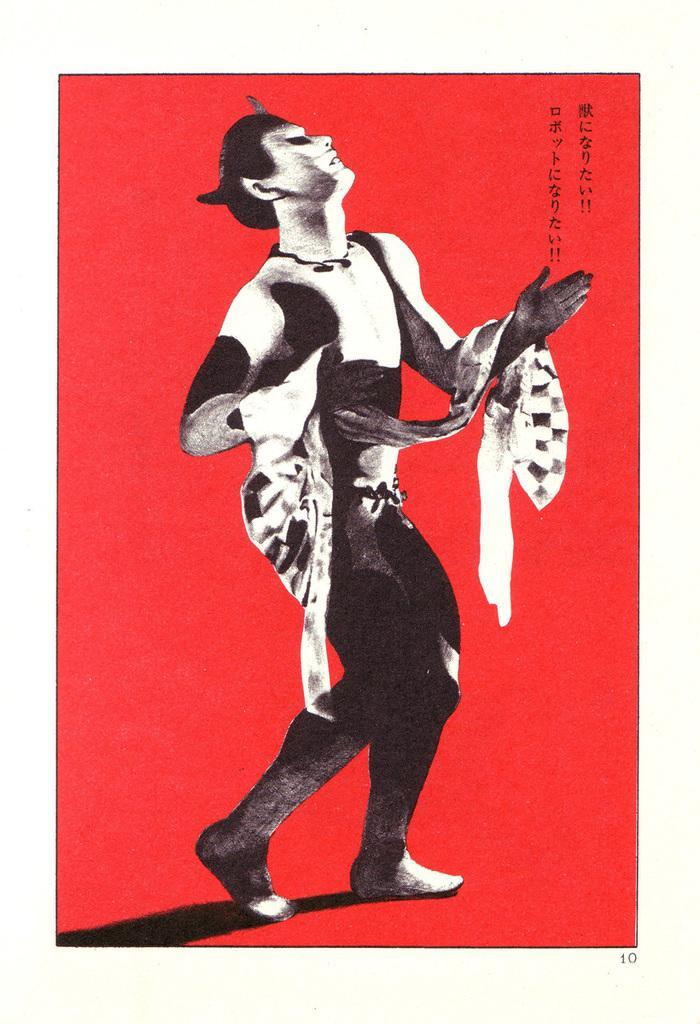Can you describe this image briefly? In this image there is a red colored background. A man is standing. We can see the shadow of the legs. 